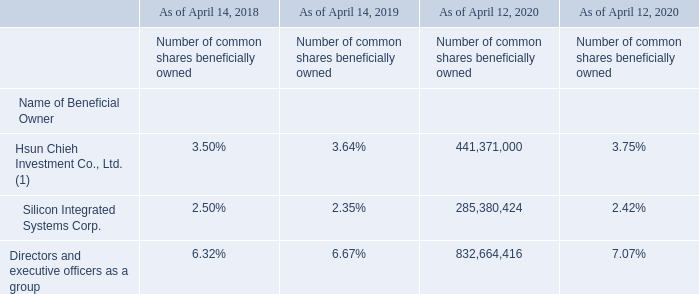The following table sets forth information known to us with respect to the beneficial ownership of our common shares as of (i) April 12, 2020, our most recent record date, and (ii) as of certain record dates in each of the preceding three years, for (1) the stockholders known by us to beneficially own more than 2% of our common shares and (2) all directors and executive officers as a group. Beneficial ownership is determined in accordance with SEC rules.
(1) 36.49% owned by United Microelectronics Corporation as of March 31, 2020.
None of our major stockholders have different voting rights from those of our other stockholders. To the best of our knowledge, we are not directly or indirectly controlled by another corporation, by any foreign government or by any other natural or legal person severally or jointly.
For information regarding our common shares held or beneficially owned by persons in the United States, see “Item 9. The Offer and Listing—A. Offer and Listing Details—Market Price Information for Our American Depositary Shares” in this annual report.
How is the Beneficial ownership determined? Beneficial ownership is determined in accordance with sec rules. Do the major stockholders have different voting rights? None of our major stockholders have different voting rights from those of our other stockholders. Is the corporation regulated by second or third party regulator? We are not directly or indirectly controlled by another corporation, by any foreign government or by any other natural or legal person severally or jointly. What is the increase/ (decrease) in number of common shares beneficially owned of Silicon Integrated Systems Corp. from April 14, 2018 to April 14, 2019?
Answer scale should be: percent. 2.35-2.50
Answer: -0.15. What is the increase/ (decrease) in number of common shares beneficially owned of Hsun Chieh Investment Co., Ltd. from April 14, 2018 to April 14, 2019?
Answer scale should be: percent. 3.64-3.50
Answer: 0.14. What is the increase/ (decrease) in number of common shares beneficially owned of Directors and executive officers as a group from April 14, 2018 to April 14, 2019?
Answer scale should be: percent. 6.67-6.32
Answer: 0.35. 